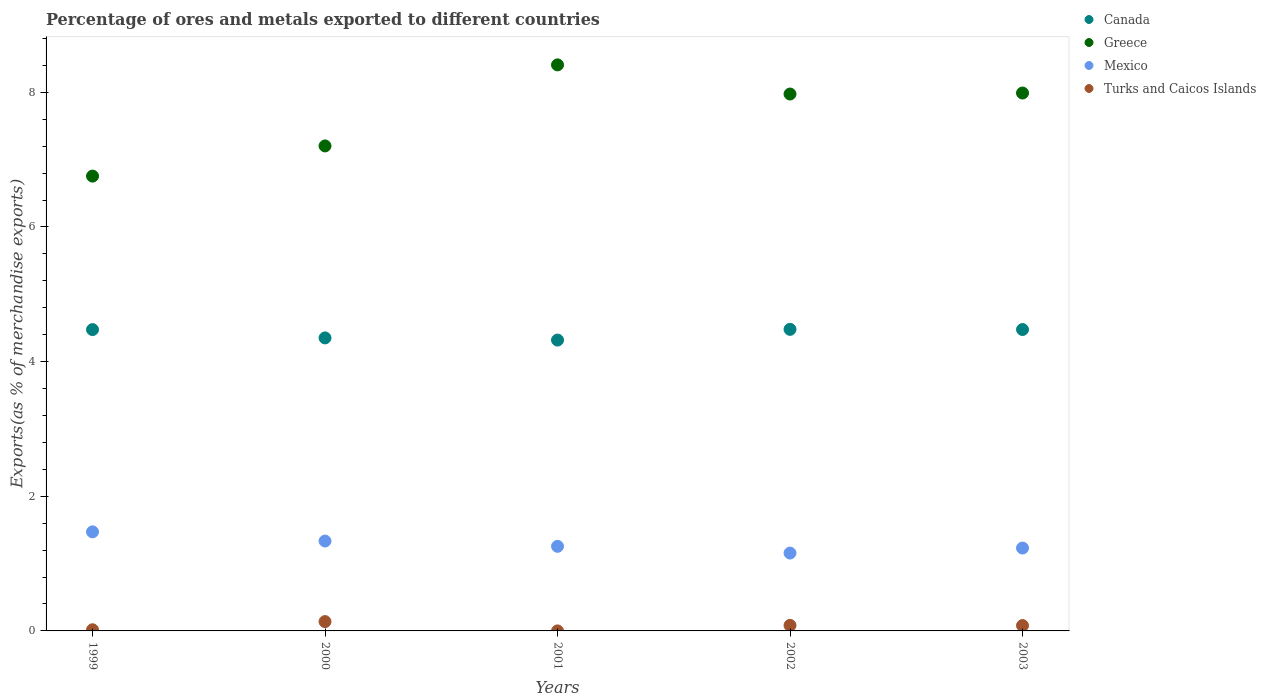How many different coloured dotlines are there?
Make the answer very short. 4. Is the number of dotlines equal to the number of legend labels?
Offer a terse response. Yes. What is the percentage of exports to different countries in Mexico in 2001?
Your answer should be compact. 1.26. Across all years, what is the maximum percentage of exports to different countries in Mexico?
Your answer should be compact. 1.47. Across all years, what is the minimum percentage of exports to different countries in Turks and Caicos Islands?
Your answer should be compact. 0. In which year was the percentage of exports to different countries in Greece maximum?
Provide a short and direct response. 2001. In which year was the percentage of exports to different countries in Greece minimum?
Provide a succinct answer. 1999. What is the total percentage of exports to different countries in Mexico in the graph?
Ensure brevity in your answer.  6.45. What is the difference between the percentage of exports to different countries in Canada in 2002 and that in 2003?
Provide a short and direct response. 0. What is the difference between the percentage of exports to different countries in Canada in 1999 and the percentage of exports to different countries in Turks and Caicos Islands in 2001?
Your answer should be very brief. 4.48. What is the average percentage of exports to different countries in Canada per year?
Give a very brief answer. 4.42. In the year 2001, what is the difference between the percentage of exports to different countries in Greece and percentage of exports to different countries in Mexico?
Your response must be concise. 7.15. What is the ratio of the percentage of exports to different countries in Turks and Caicos Islands in 1999 to that in 2003?
Ensure brevity in your answer.  0.22. Is the percentage of exports to different countries in Mexico in 2000 less than that in 2002?
Your answer should be compact. No. What is the difference between the highest and the second highest percentage of exports to different countries in Canada?
Offer a very short reply. 0. What is the difference between the highest and the lowest percentage of exports to different countries in Canada?
Provide a succinct answer. 0.16. Is the sum of the percentage of exports to different countries in Greece in 2000 and 2001 greater than the maximum percentage of exports to different countries in Turks and Caicos Islands across all years?
Offer a terse response. Yes. Is it the case that in every year, the sum of the percentage of exports to different countries in Turks and Caicos Islands and percentage of exports to different countries in Canada  is greater than the sum of percentage of exports to different countries in Mexico and percentage of exports to different countries in Greece?
Your answer should be compact. Yes. Does the percentage of exports to different countries in Canada monotonically increase over the years?
Keep it short and to the point. No. Is the percentage of exports to different countries in Greece strictly greater than the percentage of exports to different countries in Canada over the years?
Provide a short and direct response. Yes. Is the percentage of exports to different countries in Canada strictly less than the percentage of exports to different countries in Mexico over the years?
Your answer should be very brief. No. How many dotlines are there?
Provide a succinct answer. 4. How many years are there in the graph?
Your response must be concise. 5. Are the values on the major ticks of Y-axis written in scientific E-notation?
Your answer should be compact. No. Does the graph contain any zero values?
Keep it short and to the point. No. What is the title of the graph?
Provide a short and direct response. Percentage of ores and metals exported to different countries. What is the label or title of the Y-axis?
Provide a succinct answer. Exports(as % of merchandise exports). What is the Exports(as % of merchandise exports) in Canada in 1999?
Your answer should be compact. 4.48. What is the Exports(as % of merchandise exports) in Greece in 1999?
Your response must be concise. 6.76. What is the Exports(as % of merchandise exports) in Mexico in 1999?
Provide a succinct answer. 1.47. What is the Exports(as % of merchandise exports) of Turks and Caicos Islands in 1999?
Make the answer very short. 0.02. What is the Exports(as % of merchandise exports) in Canada in 2000?
Give a very brief answer. 4.35. What is the Exports(as % of merchandise exports) of Greece in 2000?
Offer a very short reply. 7.2. What is the Exports(as % of merchandise exports) in Mexico in 2000?
Your answer should be very brief. 1.33. What is the Exports(as % of merchandise exports) of Turks and Caicos Islands in 2000?
Your response must be concise. 0.14. What is the Exports(as % of merchandise exports) in Canada in 2001?
Ensure brevity in your answer.  4.32. What is the Exports(as % of merchandise exports) in Greece in 2001?
Keep it short and to the point. 8.41. What is the Exports(as % of merchandise exports) in Mexico in 2001?
Your response must be concise. 1.26. What is the Exports(as % of merchandise exports) of Turks and Caicos Islands in 2001?
Your answer should be compact. 0. What is the Exports(as % of merchandise exports) in Canada in 2002?
Provide a short and direct response. 4.48. What is the Exports(as % of merchandise exports) of Greece in 2002?
Your response must be concise. 7.97. What is the Exports(as % of merchandise exports) in Mexico in 2002?
Give a very brief answer. 1.16. What is the Exports(as % of merchandise exports) of Turks and Caicos Islands in 2002?
Provide a succinct answer. 0.08. What is the Exports(as % of merchandise exports) in Canada in 2003?
Make the answer very short. 4.48. What is the Exports(as % of merchandise exports) in Greece in 2003?
Offer a very short reply. 7.99. What is the Exports(as % of merchandise exports) of Mexico in 2003?
Your response must be concise. 1.23. What is the Exports(as % of merchandise exports) of Turks and Caicos Islands in 2003?
Provide a succinct answer. 0.08. Across all years, what is the maximum Exports(as % of merchandise exports) of Canada?
Give a very brief answer. 4.48. Across all years, what is the maximum Exports(as % of merchandise exports) in Greece?
Offer a terse response. 8.41. Across all years, what is the maximum Exports(as % of merchandise exports) in Mexico?
Offer a very short reply. 1.47. Across all years, what is the maximum Exports(as % of merchandise exports) of Turks and Caicos Islands?
Your answer should be very brief. 0.14. Across all years, what is the minimum Exports(as % of merchandise exports) of Canada?
Ensure brevity in your answer.  4.32. Across all years, what is the minimum Exports(as % of merchandise exports) of Greece?
Provide a short and direct response. 6.76. Across all years, what is the minimum Exports(as % of merchandise exports) of Mexico?
Give a very brief answer. 1.16. Across all years, what is the minimum Exports(as % of merchandise exports) of Turks and Caicos Islands?
Give a very brief answer. 0. What is the total Exports(as % of merchandise exports) of Canada in the graph?
Keep it short and to the point. 22.1. What is the total Exports(as % of merchandise exports) of Greece in the graph?
Keep it short and to the point. 38.33. What is the total Exports(as % of merchandise exports) of Mexico in the graph?
Your answer should be very brief. 6.45. What is the total Exports(as % of merchandise exports) in Turks and Caicos Islands in the graph?
Give a very brief answer. 0.32. What is the difference between the Exports(as % of merchandise exports) of Canada in 1999 and that in 2000?
Your response must be concise. 0.12. What is the difference between the Exports(as % of merchandise exports) in Greece in 1999 and that in 2000?
Provide a short and direct response. -0.45. What is the difference between the Exports(as % of merchandise exports) of Mexico in 1999 and that in 2000?
Keep it short and to the point. 0.14. What is the difference between the Exports(as % of merchandise exports) of Turks and Caicos Islands in 1999 and that in 2000?
Ensure brevity in your answer.  -0.12. What is the difference between the Exports(as % of merchandise exports) of Canada in 1999 and that in 2001?
Provide a succinct answer. 0.16. What is the difference between the Exports(as % of merchandise exports) of Greece in 1999 and that in 2001?
Give a very brief answer. -1.65. What is the difference between the Exports(as % of merchandise exports) of Mexico in 1999 and that in 2001?
Provide a succinct answer. 0.21. What is the difference between the Exports(as % of merchandise exports) in Turks and Caicos Islands in 1999 and that in 2001?
Your answer should be compact. 0.02. What is the difference between the Exports(as % of merchandise exports) in Canada in 1999 and that in 2002?
Give a very brief answer. -0. What is the difference between the Exports(as % of merchandise exports) in Greece in 1999 and that in 2002?
Provide a succinct answer. -1.22. What is the difference between the Exports(as % of merchandise exports) of Mexico in 1999 and that in 2002?
Make the answer very short. 0.32. What is the difference between the Exports(as % of merchandise exports) in Turks and Caicos Islands in 1999 and that in 2002?
Provide a short and direct response. -0.07. What is the difference between the Exports(as % of merchandise exports) of Canada in 1999 and that in 2003?
Your answer should be very brief. -0. What is the difference between the Exports(as % of merchandise exports) of Greece in 1999 and that in 2003?
Keep it short and to the point. -1.23. What is the difference between the Exports(as % of merchandise exports) in Mexico in 1999 and that in 2003?
Your response must be concise. 0.24. What is the difference between the Exports(as % of merchandise exports) of Turks and Caicos Islands in 1999 and that in 2003?
Your response must be concise. -0.06. What is the difference between the Exports(as % of merchandise exports) of Canada in 2000 and that in 2001?
Your answer should be very brief. 0.03. What is the difference between the Exports(as % of merchandise exports) in Greece in 2000 and that in 2001?
Your answer should be very brief. -1.2. What is the difference between the Exports(as % of merchandise exports) in Mexico in 2000 and that in 2001?
Provide a short and direct response. 0.08. What is the difference between the Exports(as % of merchandise exports) of Turks and Caicos Islands in 2000 and that in 2001?
Offer a very short reply. 0.14. What is the difference between the Exports(as % of merchandise exports) in Canada in 2000 and that in 2002?
Give a very brief answer. -0.13. What is the difference between the Exports(as % of merchandise exports) in Greece in 2000 and that in 2002?
Your answer should be compact. -0.77. What is the difference between the Exports(as % of merchandise exports) in Mexico in 2000 and that in 2002?
Offer a terse response. 0.18. What is the difference between the Exports(as % of merchandise exports) of Turks and Caicos Islands in 2000 and that in 2002?
Give a very brief answer. 0.06. What is the difference between the Exports(as % of merchandise exports) in Canada in 2000 and that in 2003?
Make the answer very short. -0.12. What is the difference between the Exports(as % of merchandise exports) in Greece in 2000 and that in 2003?
Your answer should be very brief. -0.79. What is the difference between the Exports(as % of merchandise exports) of Mexico in 2000 and that in 2003?
Ensure brevity in your answer.  0.1. What is the difference between the Exports(as % of merchandise exports) of Turks and Caicos Islands in 2000 and that in 2003?
Ensure brevity in your answer.  0.06. What is the difference between the Exports(as % of merchandise exports) in Canada in 2001 and that in 2002?
Your answer should be compact. -0.16. What is the difference between the Exports(as % of merchandise exports) of Greece in 2001 and that in 2002?
Ensure brevity in your answer.  0.43. What is the difference between the Exports(as % of merchandise exports) in Mexico in 2001 and that in 2002?
Keep it short and to the point. 0.1. What is the difference between the Exports(as % of merchandise exports) in Turks and Caicos Islands in 2001 and that in 2002?
Give a very brief answer. -0.08. What is the difference between the Exports(as % of merchandise exports) in Canada in 2001 and that in 2003?
Your answer should be compact. -0.16. What is the difference between the Exports(as % of merchandise exports) of Greece in 2001 and that in 2003?
Keep it short and to the point. 0.42. What is the difference between the Exports(as % of merchandise exports) of Mexico in 2001 and that in 2003?
Keep it short and to the point. 0.03. What is the difference between the Exports(as % of merchandise exports) of Turks and Caicos Islands in 2001 and that in 2003?
Offer a very short reply. -0.08. What is the difference between the Exports(as % of merchandise exports) in Canada in 2002 and that in 2003?
Your response must be concise. 0. What is the difference between the Exports(as % of merchandise exports) of Greece in 2002 and that in 2003?
Your answer should be very brief. -0.01. What is the difference between the Exports(as % of merchandise exports) in Mexico in 2002 and that in 2003?
Keep it short and to the point. -0.07. What is the difference between the Exports(as % of merchandise exports) of Turks and Caicos Islands in 2002 and that in 2003?
Offer a very short reply. 0. What is the difference between the Exports(as % of merchandise exports) of Canada in 1999 and the Exports(as % of merchandise exports) of Greece in 2000?
Your answer should be compact. -2.73. What is the difference between the Exports(as % of merchandise exports) of Canada in 1999 and the Exports(as % of merchandise exports) of Mexico in 2000?
Provide a succinct answer. 3.14. What is the difference between the Exports(as % of merchandise exports) in Canada in 1999 and the Exports(as % of merchandise exports) in Turks and Caicos Islands in 2000?
Offer a very short reply. 4.34. What is the difference between the Exports(as % of merchandise exports) in Greece in 1999 and the Exports(as % of merchandise exports) in Mexico in 2000?
Your answer should be very brief. 5.42. What is the difference between the Exports(as % of merchandise exports) in Greece in 1999 and the Exports(as % of merchandise exports) in Turks and Caicos Islands in 2000?
Make the answer very short. 6.62. What is the difference between the Exports(as % of merchandise exports) in Mexico in 1999 and the Exports(as % of merchandise exports) in Turks and Caicos Islands in 2000?
Offer a terse response. 1.33. What is the difference between the Exports(as % of merchandise exports) of Canada in 1999 and the Exports(as % of merchandise exports) of Greece in 2001?
Offer a terse response. -3.93. What is the difference between the Exports(as % of merchandise exports) of Canada in 1999 and the Exports(as % of merchandise exports) of Mexico in 2001?
Your response must be concise. 3.22. What is the difference between the Exports(as % of merchandise exports) in Canada in 1999 and the Exports(as % of merchandise exports) in Turks and Caicos Islands in 2001?
Keep it short and to the point. 4.48. What is the difference between the Exports(as % of merchandise exports) in Greece in 1999 and the Exports(as % of merchandise exports) in Mexico in 2001?
Provide a succinct answer. 5.5. What is the difference between the Exports(as % of merchandise exports) of Greece in 1999 and the Exports(as % of merchandise exports) of Turks and Caicos Islands in 2001?
Your answer should be compact. 6.76. What is the difference between the Exports(as % of merchandise exports) in Mexico in 1999 and the Exports(as % of merchandise exports) in Turks and Caicos Islands in 2001?
Your answer should be compact. 1.47. What is the difference between the Exports(as % of merchandise exports) of Canada in 1999 and the Exports(as % of merchandise exports) of Greece in 2002?
Make the answer very short. -3.5. What is the difference between the Exports(as % of merchandise exports) of Canada in 1999 and the Exports(as % of merchandise exports) of Mexico in 2002?
Offer a very short reply. 3.32. What is the difference between the Exports(as % of merchandise exports) in Canada in 1999 and the Exports(as % of merchandise exports) in Turks and Caicos Islands in 2002?
Provide a short and direct response. 4.39. What is the difference between the Exports(as % of merchandise exports) in Greece in 1999 and the Exports(as % of merchandise exports) in Mexico in 2002?
Your response must be concise. 5.6. What is the difference between the Exports(as % of merchandise exports) of Greece in 1999 and the Exports(as % of merchandise exports) of Turks and Caicos Islands in 2002?
Offer a very short reply. 6.67. What is the difference between the Exports(as % of merchandise exports) of Mexico in 1999 and the Exports(as % of merchandise exports) of Turks and Caicos Islands in 2002?
Provide a succinct answer. 1.39. What is the difference between the Exports(as % of merchandise exports) of Canada in 1999 and the Exports(as % of merchandise exports) of Greece in 2003?
Keep it short and to the point. -3.51. What is the difference between the Exports(as % of merchandise exports) of Canada in 1999 and the Exports(as % of merchandise exports) of Mexico in 2003?
Ensure brevity in your answer.  3.24. What is the difference between the Exports(as % of merchandise exports) in Canada in 1999 and the Exports(as % of merchandise exports) in Turks and Caicos Islands in 2003?
Keep it short and to the point. 4.4. What is the difference between the Exports(as % of merchandise exports) of Greece in 1999 and the Exports(as % of merchandise exports) of Mexico in 2003?
Provide a succinct answer. 5.52. What is the difference between the Exports(as % of merchandise exports) of Greece in 1999 and the Exports(as % of merchandise exports) of Turks and Caicos Islands in 2003?
Offer a terse response. 6.68. What is the difference between the Exports(as % of merchandise exports) in Mexico in 1999 and the Exports(as % of merchandise exports) in Turks and Caicos Islands in 2003?
Make the answer very short. 1.39. What is the difference between the Exports(as % of merchandise exports) in Canada in 2000 and the Exports(as % of merchandise exports) in Greece in 2001?
Ensure brevity in your answer.  -4.06. What is the difference between the Exports(as % of merchandise exports) in Canada in 2000 and the Exports(as % of merchandise exports) in Mexico in 2001?
Provide a succinct answer. 3.1. What is the difference between the Exports(as % of merchandise exports) in Canada in 2000 and the Exports(as % of merchandise exports) in Turks and Caicos Islands in 2001?
Offer a very short reply. 4.35. What is the difference between the Exports(as % of merchandise exports) in Greece in 2000 and the Exports(as % of merchandise exports) in Mexico in 2001?
Offer a very short reply. 5.95. What is the difference between the Exports(as % of merchandise exports) in Greece in 2000 and the Exports(as % of merchandise exports) in Turks and Caicos Islands in 2001?
Ensure brevity in your answer.  7.2. What is the difference between the Exports(as % of merchandise exports) of Mexico in 2000 and the Exports(as % of merchandise exports) of Turks and Caicos Islands in 2001?
Keep it short and to the point. 1.33. What is the difference between the Exports(as % of merchandise exports) of Canada in 2000 and the Exports(as % of merchandise exports) of Greece in 2002?
Offer a terse response. -3.62. What is the difference between the Exports(as % of merchandise exports) in Canada in 2000 and the Exports(as % of merchandise exports) in Mexico in 2002?
Offer a very short reply. 3.2. What is the difference between the Exports(as % of merchandise exports) of Canada in 2000 and the Exports(as % of merchandise exports) of Turks and Caicos Islands in 2002?
Provide a short and direct response. 4.27. What is the difference between the Exports(as % of merchandise exports) in Greece in 2000 and the Exports(as % of merchandise exports) in Mexico in 2002?
Give a very brief answer. 6.05. What is the difference between the Exports(as % of merchandise exports) in Greece in 2000 and the Exports(as % of merchandise exports) in Turks and Caicos Islands in 2002?
Offer a very short reply. 7.12. What is the difference between the Exports(as % of merchandise exports) in Mexico in 2000 and the Exports(as % of merchandise exports) in Turks and Caicos Islands in 2002?
Provide a short and direct response. 1.25. What is the difference between the Exports(as % of merchandise exports) of Canada in 2000 and the Exports(as % of merchandise exports) of Greece in 2003?
Offer a terse response. -3.64. What is the difference between the Exports(as % of merchandise exports) of Canada in 2000 and the Exports(as % of merchandise exports) of Mexico in 2003?
Your response must be concise. 3.12. What is the difference between the Exports(as % of merchandise exports) in Canada in 2000 and the Exports(as % of merchandise exports) in Turks and Caicos Islands in 2003?
Keep it short and to the point. 4.27. What is the difference between the Exports(as % of merchandise exports) of Greece in 2000 and the Exports(as % of merchandise exports) of Mexico in 2003?
Offer a terse response. 5.97. What is the difference between the Exports(as % of merchandise exports) of Greece in 2000 and the Exports(as % of merchandise exports) of Turks and Caicos Islands in 2003?
Your response must be concise. 7.12. What is the difference between the Exports(as % of merchandise exports) in Mexico in 2000 and the Exports(as % of merchandise exports) in Turks and Caicos Islands in 2003?
Offer a very short reply. 1.26. What is the difference between the Exports(as % of merchandise exports) of Canada in 2001 and the Exports(as % of merchandise exports) of Greece in 2002?
Offer a terse response. -3.65. What is the difference between the Exports(as % of merchandise exports) of Canada in 2001 and the Exports(as % of merchandise exports) of Mexico in 2002?
Your response must be concise. 3.16. What is the difference between the Exports(as % of merchandise exports) of Canada in 2001 and the Exports(as % of merchandise exports) of Turks and Caicos Islands in 2002?
Give a very brief answer. 4.24. What is the difference between the Exports(as % of merchandise exports) of Greece in 2001 and the Exports(as % of merchandise exports) of Mexico in 2002?
Give a very brief answer. 7.25. What is the difference between the Exports(as % of merchandise exports) in Greece in 2001 and the Exports(as % of merchandise exports) in Turks and Caicos Islands in 2002?
Your answer should be compact. 8.33. What is the difference between the Exports(as % of merchandise exports) in Mexico in 2001 and the Exports(as % of merchandise exports) in Turks and Caicos Islands in 2002?
Offer a terse response. 1.17. What is the difference between the Exports(as % of merchandise exports) of Canada in 2001 and the Exports(as % of merchandise exports) of Greece in 2003?
Ensure brevity in your answer.  -3.67. What is the difference between the Exports(as % of merchandise exports) in Canada in 2001 and the Exports(as % of merchandise exports) in Mexico in 2003?
Keep it short and to the point. 3.09. What is the difference between the Exports(as % of merchandise exports) of Canada in 2001 and the Exports(as % of merchandise exports) of Turks and Caicos Islands in 2003?
Your answer should be very brief. 4.24. What is the difference between the Exports(as % of merchandise exports) of Greece in 2001 and the Exports(as % of merchandise exports) of Mexico in 2003?
Provide a succinct answer. 7.18. What is the difference between the Exports(as % of merchandise exports) of Greece in 2001 and the Exports(as % of merchandise exports) of Turks and Caicos Islands in 2003?
Provide a short and direct response. 8.33. What is the difference between the Exports(as % of merchandise exports) of Mexico in 2001 and the Exports(as % of merchandise exports) of Turks and Caicos Islands in 2003?
Offer a terse response. 1.18. What is the difference between the Exports(as % of merchandise exports) of Canada in 2002 and the Exports(as % of merchandise exports) of Greece in 2003?
Keep it short and to the point. -3.51. What is the difference between the Exports(as % of merchandise exports) in Canada in 2002 and the Exports(as % of merchandise exports) in Mexico in 2003?
Your response must be concise. 3.25. What is the difference between the Exports(as % of merchandise exports) in Canada in 2002 and the Exports(as % of merchandise exports) in Turks and Caicos Islands in 2003?
Provide a succinct answer. 4.4. What is the difference between the Exports(as % of merchandise exports) in Greece in 2002 and the Exports(as % of merchandise exports) in Mexico in 2003?
Provide a short and direct response. 6.74. What is the difference between the Exports(as % of merchandise exports) of Greece in 2002 and the Exports(as % of merchandise exports) of Turks and Caicos Islands in 2003?
Provide a short and direct response. 7.9. What is the difference between the Exports(as % of merchandise exports) of Mexico in 2002 and the Exports(as % of merchandise exports) of Turks and Caicos Islands in 2003?
Offer a terse response. 1.08. What is the average Exports(as % of merchandise exports) of Canada per year?
Your answer should be compact. 4.42. What is the average Exports(as % of merchandise exports) in Greece per year?
Your response must be concise. 7.67. What is the average Exports(as % of merchandise exports) of Mexico per year?
Ensure brevity in your answer.  1.29. What is the average Exports(as % of merchandise exports) of Turks and Caicos Islands per year?
Provide a short and direct response. 0.06. In the year 1999, what is the difference between the Exports(as % of merchandise exports) of Canada and Exports(as % of merchandise exports) of Greece?
Your response must be concise. -2.28. In the year 1999, what is the difference between the Exports(as % of merchandise exports) of Canada and Exports(as % of merchandise exports) of Mexico?
Provide a short and direct response. 3. In the year 1999, what is the difference between the Exports(as % of merchandise exports) in Canada and Exports(as % of merchandise exports) in Turks and Caicos Islands?
Ensure brevity in your answer.  4.46. In the year 1999, what is the difference between the Exports(as % of merchandise exports) in Greece and Exports(as % of merchandise exports) in Mexico?
Provide a short and direct response. 5.28. In the year 1999, what is the difference between the Exports(as % of merchandise exports) in Greece and Exports(as % of merchandise exports) in Turks and Caicos Islands?
Provide a short and direct response. 6.74. In the year 1999, what is the difference between the Exports(as % of merchandise exports) of Mexico and Exports(as % of merchandise exports) of Turks and Caicos Islands?
Give a very brief answer. 1.45. In the year 2000, what is the difference between the Exports(as % of merchandise exports) in Canada and Exports(as % of merchandise exports) in Greece?
Ensure brevity in your answer.  -2.85. In the year 2000, what is the difference between the Exports(as % of merchandise exports) in Canada and Exports(as % of merchandise exports) in Mexico?
Offer a terse response. 3.02. In the year 2000, what is the difference between the Exports(as % of merchandise exports) of Canada and Exports(as % of merchandise exports) of Turks and Caicos Islands?
Provide a short and direct response. 4.21. In the year 2000, what is the difference between the Exports(as % of merchandise exports) in Greece and Exports(as % of merchandise exports) in Mexico?
Give a very brief answer. 5.87. In the year 2000, what is the difference between the Exports(as % of merchandise exports) of Greece and Exports(as % of merchandise exports) of Turks and Caicos Islands?
Provide a succinct answer. 7.07. In the year 2000, what is the difference between the Exports(as % of merchandise exports) of Mexico and Exports(as % of merchandise exports) of Turks and Caicos Islands?
Keep it short and to the point. 1.2. In the year 2001, what is the difference between the Exports(as % of merchandise exports) in Canada and Exports(as % of merchandise exports) in Greece?
Keep it short and to the point. -4.09. In the year 2001, what is the difference between the Exports(as % of merchandise exports) in Canada and Exports(as % of merchandise exports) in Mexico?
Offer a terse response. 3.06. In the year 2001, what is the difference between the Exports(as % of merchandise exports) of Canada and Exports(as % of merchandise exports) of Turks and Caicos Islands?
Your response must be concise. 4.32. In the year 2001, what is the difference between the Exports(as % of merchandise exports) of Greece and Exports(as % of merchandise exports) of Mexico?
Give a very brief answer. 7.15. In the year 2001, what is the difference between the Exports(as % of merchandise exports) of Greece and Exports(as % of merchandise exports) of Turks and Caicos Islands?
Your answer should be compact. 8.41. In the year 2001, what is the difference between the Exports(as % of merchandise exports) in Mexico and Exports(as % of merchandise exports) in Turks and Caicos Islands?
Your response must be concise. 1.26. In the year 2002, what is the difference between the Exports(as % of merchandise exports) of Canada and Exports(as % of merchandise exports) of Greece?
Give a very brief answer. -3.5. In the year 2002, what is the difference between the Exports(as % of merchandise exports) in Canada and Exports(as % of merchandise exports) in Mexico?
Give a very brief answer. 3.32. In the year 2002, what is the difference between the Exports(as % of merchandise exports) in Canada and Exports(as % of merchandise exports) in Turks and Caicos Islands?
Your response must be concise. 4.4. In the year 2002, what is the difference between the Exports(as % of merchandise exports) of Greece and Exports(as % of merchandise exports) of Mexico?
Ensure brevity in your answer.  6.82. In the year 2002, what is the difference between the Exports(as % of merchandise exports) in Greece and Exports(as % of merchandise exports) in Turks and Caicos Islands?
Your answer should be very brief. 7.89. In the year 2002, what is the difference between the Exports(as % of merchandise exports) of Mexico and Exports(as % of merchandise exports) of Turks and Caicos Islands?
Ensure brevity in your answer.  1.07. In the year 2003, what is the difference between the Exports(as % of merchandise exports) of Canada and Exports(as % of merchandise exports) of Greece?
Your answer should be compact. -3.51. In the year 2003, what is the difference between the Exports(as % of merchandise exports) in Canada and Exports(as % of merchandise exports) in Mexico?
Offer a terse response. 3.25. In the year 2003, what is the difference between the Exports(as % of merchandise exports) in Canada and Exports(as % of merchandise exports) in Turks and Caicos Islands?
Give a very brief answer. 4.4. In the year 2003, what is the difference between the Exports(as % of merchandise exports) in Greece and Exports(as % of merchandise exports) in Mexico?
Your answer should be very brief. 6.76. In the year 2003, what is the difference between the Exports(as % of merchandise exports) in Greece and Exports(as % of merchandise exports) in Turks and Caicos Islands?
Provide a succinct answer. 7.91. In the year 2003, what is the difference between the Exports(as % of merchandise exports) in Mexico and Exports(as % of merchandise exports) in Turks and Caicos Islands?
Provide a succinct answer. 1.15. What is the ratio of the Exports(as % of merchandise exports) in Canada in 1999 to that in 2000?
Give a very brief answer. 1.03. What is the ratio of the Exports(as % of merchandise exports) of Greece in 1999 to that in 2000?
Your response must be concise. 0.94. What is the ratio of the Exports(as % of merchandise exports) in Mexico in 1999 to that in 2000?
Make the answer very short. 1.1. What is the ratio of the Exports(as % of merchandise exports) in Turks and Caicos Islands in 1999 to that in 2000?
Make the answer very short. 0.12. What is the ratio of the Exports(as % of merchandise exports) of Canada in 1999 to that in 2001?
Your response must be concise. 1.04. What is the ratio of the Exports(as % of merchandise exports) in Greece in 1999 to that in 2001?
Provide a short and direct response. 0.8. What is the ratio of the Exports(as % of merchandise exports) of Mexico in 1999 to that in 2001?
Provide a succinct answer. 1.17. What is the ratio of the Exports(as % of merchandise exports) in Turks and Caicos Islands in 1999 to that in 2001?
Ensure brevity in your answer.  81.53. What is the ratio of the Exports(as % of merchandise exports) in Greece in 1999 to that in 2002?
Ensure brevity in your answer.  0.85. What is the ratio of the Exports(as % of merchandise exports) in Mexico in 1999 to that in 2002?
Provide a short and direct response. 1.27. What is the ratio of the Exports(as % of merchandise exports) in Turks and Caicos Islands in 1999 to that in 2002?
Your answer should be very brief. 0.21. What is the ratio of the Exports(as % of merchandise exports) of Canada in 1999 to that in 2003?
Offer a terse response. 1. What is the ratio of the Exports(as % of merchandise exports) in Greece in 1999 to that in 2003?
Give a very brief answer. 0.85. What is the ratio of the Exports(as % of merchandise exports) of Mexico in 1999 to that in 2003?
Your response must be concise. 1.2. What is the ratio of the Exports(as % of merchandise exports) of Turks and Caicos Islands in 1999 to that in 2003?
Your answer should be compact. 0.22. What is the ratio of the Exports(as % of merchandise exports) of Canada in 2000 to that in 2001?
Offer a very short reply. 1.01. What is the ratio of the Exports(as % of merchandise exports) of Greece in 2000 to that in 2001?
Give a very brief answer. 0.86. What is the ratio of the Exports(as % of merchandise exports) in Mexico in 2000 to that in 2001?
Provide a succinct answer. 1.06. What is the ratio of the Exports(as % of merchandise exports) in Turks and Caicos Islands in 2000 to that in 2001?
Your response must be concise. 653.05. What is the ratio of the Exports(as % of merchandise exports) of Canada in 2000 to that in 2002?
Give a very brief answer. 0.97. What is the ratio of the Exports(as % of merchandise exports) of Greece in 2000 to that in 2002?
Ensure brevity in your answer.  0.9. What is the ratio of the Exports(as % of merchandise exports) in Mexico in 2000 to that in 2002?
Provide a short and direct response. 1.15. What is the ratio of the Exports(as % of merchandise exports) of Turks and Caicos Islands in 2000 to that in 2002?
Keep it short and to the point. 1.68. What is the ratio of the Exports(as % of merchandise exports) of Canada in 2000 to that in 2003?
Give a very brief answer. 0.97. What is the ratio of the Exports(as % of merchandise exports) of Greece in 2000 to that in 2003?
Keep it short and to the point. 0.9. What is the ratio of the Exports(as % of merchandise exports) of Mexico in 2000 to that in 2003?
Ensure brevity in your answer.  1.08. What is the ratio of the Exports(as % of merchandise exports) in Turks and Caicos Islands in 2000 to that in 2003?
Your response must be concise. 1.73. What is the ratio of the Exports(as % of merchandise exports) in Canada in 2001 to that in 2002?
Offer a very short reply. 0.96. What is the ratio of the Exports(as % of merchandise exports) of Greece in 2001 to that in 2002?
Provide a succinct answer. 1.05. What is the ratio of the Exports(as % of merchandise exports) in Mexico in 2001 to that in 2002?
Your response must be concise. 1.09. What is the ratio of the Exports(as % of merchandise exports) of Turks and Caicos Islands in 2001 to that in 2002?
Your response must be concise. 0. What is the ratio of the Exports(as % of merchandise exports) of Greece in 2001 to that in 2003?
Provide a short and direct response. 1.05. What is the ratio of the Exports(as % of merchandise exports) in Mexico in 2001 to that in 2003?
Your answer should be very brief. 1.02. What is the ratio of the Exports(as % of merchandise exports) in Turks and Caicos Islands in 2001 to that in 2003?
Keep it short and to the point. 0. What is the ratio of the Exports(as % of merchandise exports) in Canada in 2002 to that in 2003?
Offer a terse response. 1. What is the ratio of the Exports(as % of merchandise exports) of Greece in 2002 to that in 2003?
Keep it short and to the point. 1. What is the ratio of the Exports(as % of merchandise exports) of Mexico in 2002 to that in 2003?
Give a very brief answer. 0.94. What is the ratio of the Exports(as % of merchandise exports) in Turks and Caicos Islands in 2002 to that in 2003?
Your response must be concise. 1.03. What is the difference between the highest and the second highest Exports(as % of merchandise exports) of Canada?
Your answer should be compact. 0. What is the difference between the highest and the second highest Exports(as % of merchandise exports) of Greece?
Offer a terse response. 0.42. What is the difference between the highest and the second highest Exports(as % of merchandise exports) of Mexico?
Offer a terse response. 0.14. What is the difference between the highest and the second highest Exports(as % of merchandise exports) in Turks and Caicos Islands?
Offer a very short reply. 0.06. What is the difference between the highest and the lowest Exports(as % of merchandise exports) of Canada?
Provide a short and direct response. 0.16. What is the difference between the highest and the lowest Exports(as % of merchandise exports) in Greece?
Provide a short and direct response. 1.65. What is the difference between the highest and the lowest Exports(as % of merchandise exports) of Mexico?
Offer a terse response. 0.32. What is the difference between the highest and the lowest Exports(as % of merchandise exports) in Turks and Caicos Islands?
Your answer should be very brief. 0.14. 